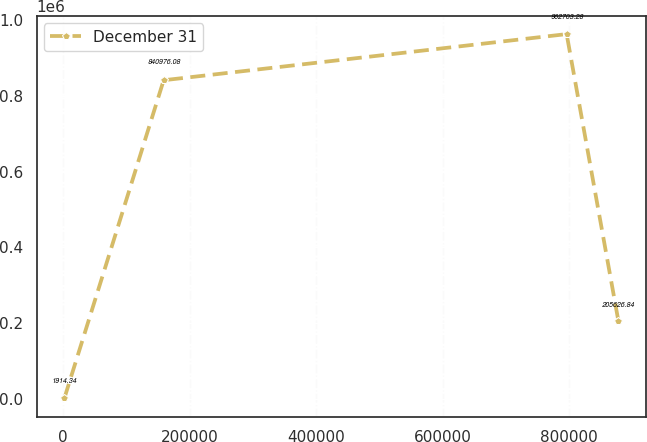Convert chart to OTSL. <chart><loc_0><loc_0><loc_500><loc_500><line_chart><ecel><fcel>December 31<nl><fcel>2070.4<fcel>1914.34<nl><fcel>158965<fcel>840976<nl><fcel>795754<fcel>962703<nl><fcel>877540<fcel>205627<nl></chart> 